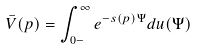Convert formula to latex. <formula><loc_0><loc_0><loc_500><loc_500>\bar { V } ( p ) = \int _ { 0 - } ^ { \infty } e ^ { - s ( p ) \Psi } d u ( \Psi )</formula> 